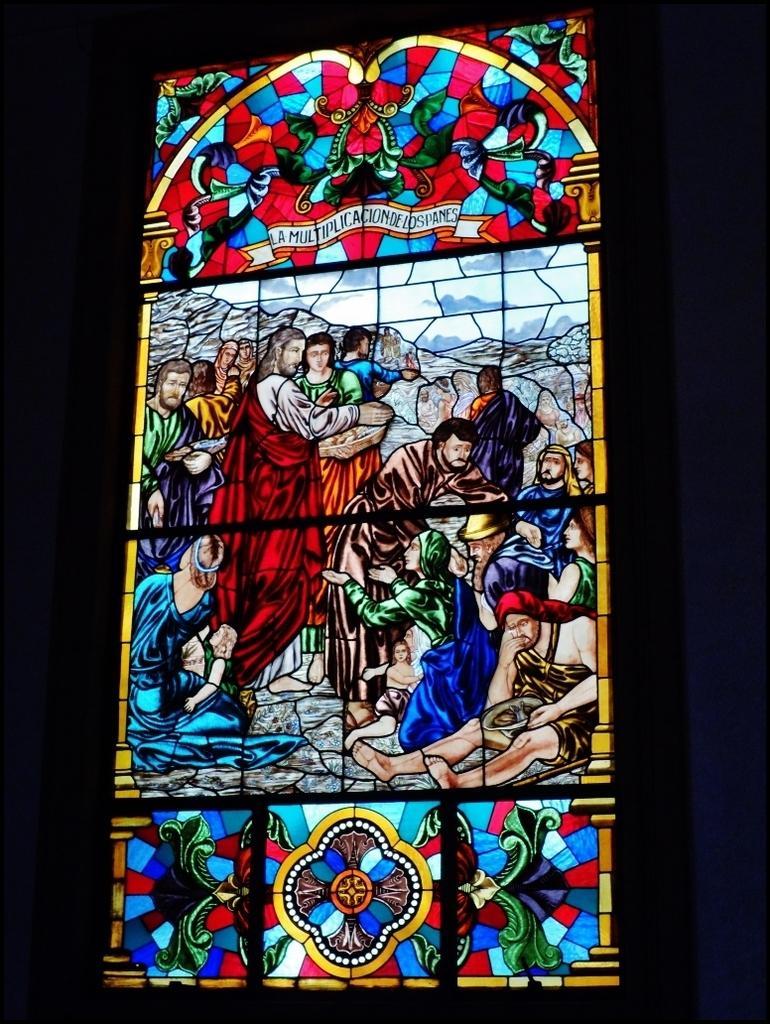Could you give a brief overview of what you see in this image? In this image we can see the stained glass on which we can see the pictures of a few people. The background of the image is dark. 